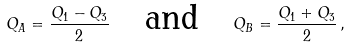<formula> <loc_0><loc_0><loc_500><loc_500>Q _ { A } = \frac { Q _ { 1 } - Q _ { 3 } } { 2 } \quad \text {and} \quad Q _ { B } = \frac { Q _ { 1 } + Q _ { 3 } } { 2 } \, ,</formula> 